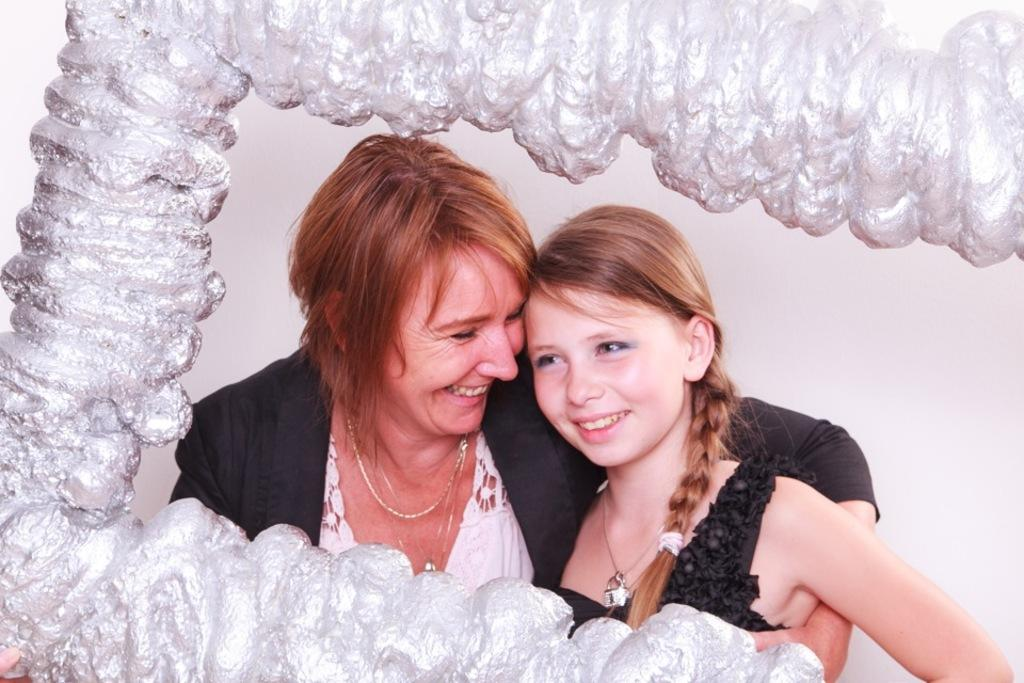Who are the people in the image? There is a woman and a girl in the image. What are the expressions on their faces? Both the woman and the girl are smiling. What color are their dresses? They are both wearing black color dresses. What is the material surrounding them? Yarn fiber is visible around them. What type of shock can be seen on the top of the girl's head in the image? There is no shock present on the top of the girl's head in the image. 